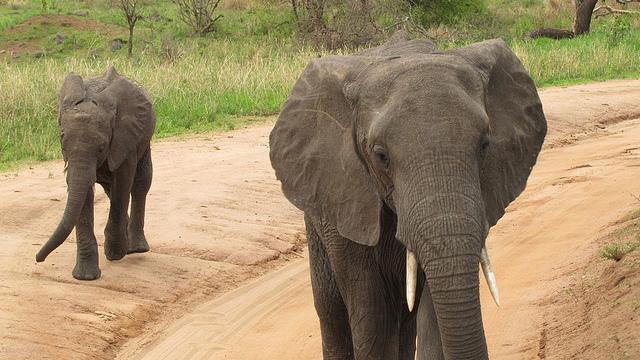Are they old?
Concise answer only. No. Are these elephants walking on a street?
Answer briefly. No. What size are the elephant on the right's ears?
Short answer required. Large. How many tusk?
Be succinct. 2. 